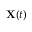<formula> <loc_0><loc_0><loc_500><loc_500>X ( t )</formula> 